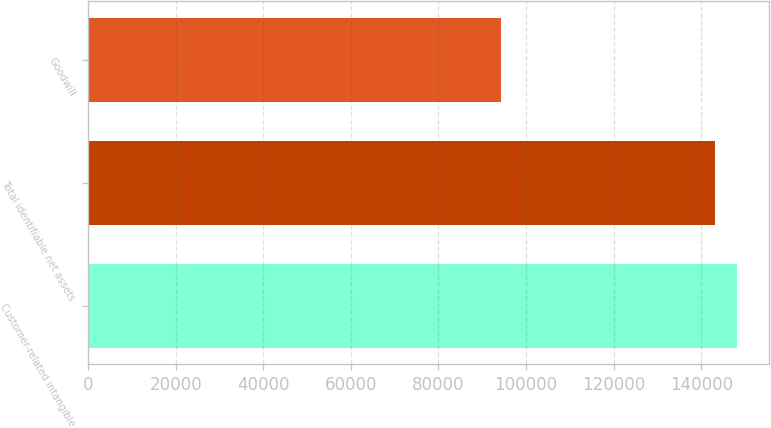<chart> <loc_0><loc_0><loc_500><loc_500><bar_chart><fcel>Customer-related intangible<fcel>Total identifiable net assets<fcel>Goodwill<nl><fcel>148165<fcel>143250<fcel>94250<nl></chart> 